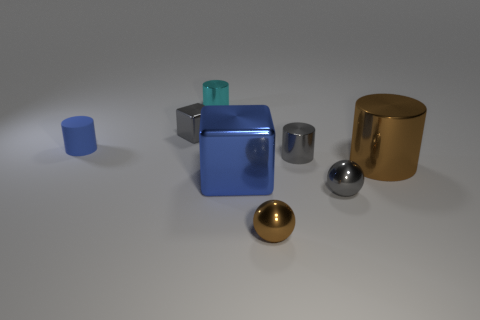Subtract all purple cylinders. Subtract all gray cubes. How many cylinders are left? 4 Add 1 small gray balls. How many objects exist? 9 Subtract all spheres. How many objects are left? 6 Subtract 1 blue cylinders. How many objects are left? 7 Subtract all blue matte things. Subtract all small blue things. How many objects are left? 6 Add 6 small balls. How many small balls are left? 8 Add 2 large green metallic cylinders. How many large green metallic cylinders exist? 2 